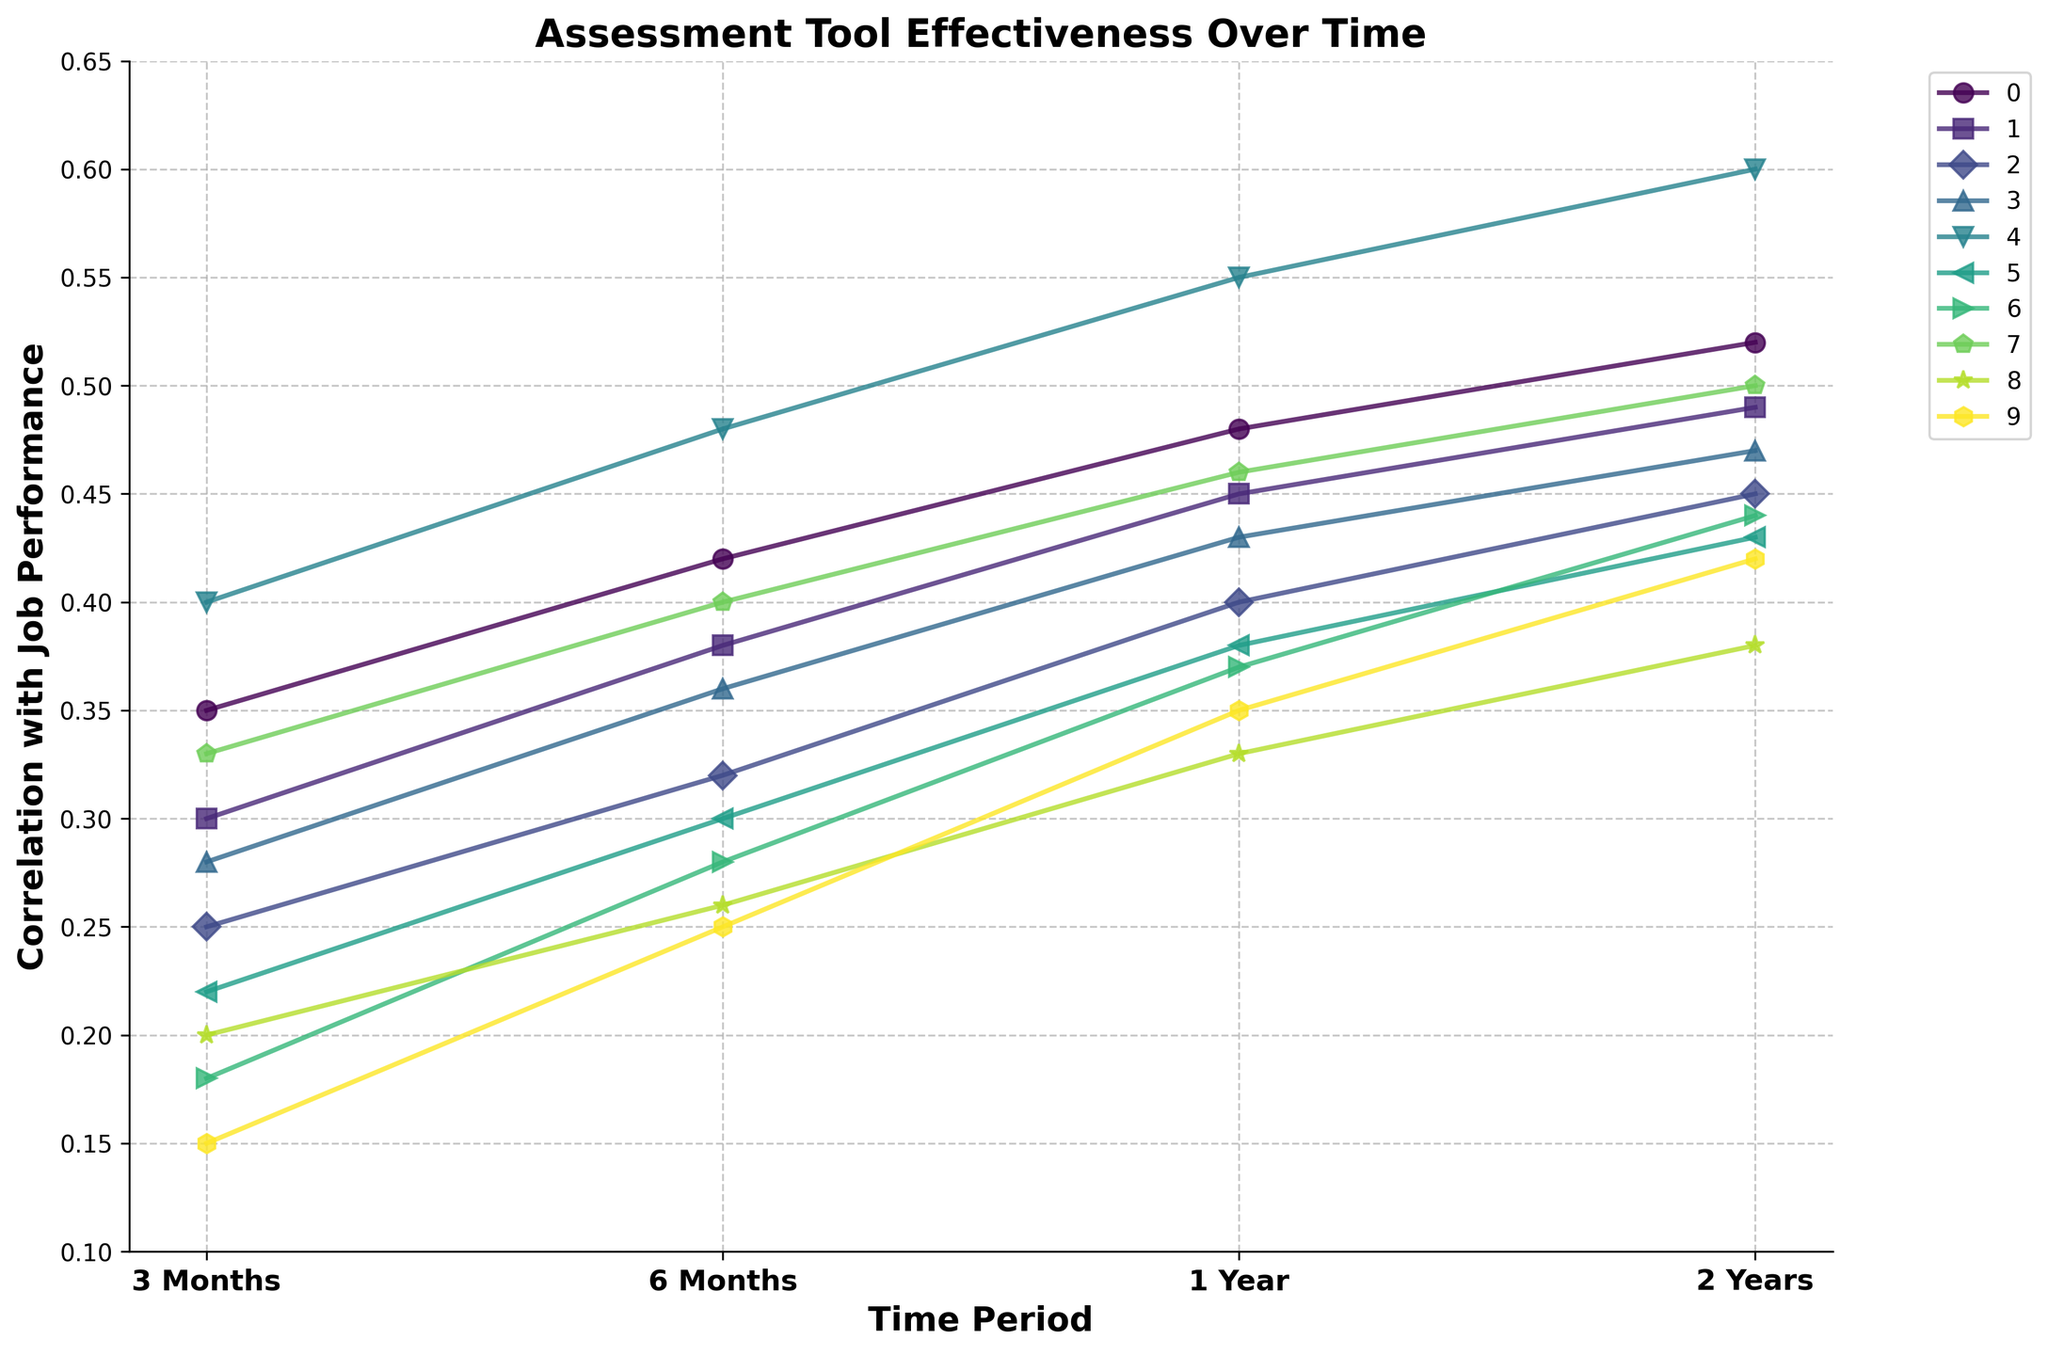What assessment tool shows the highest correlation with job performance after 6 months? Locate the point corresponding to the '6 Months' time period across all lines, and identify the highest point. The Work Sample Test shows the highest correlation score at 6 months.
Answer: Work Sample Test Which assessment tool has the lowest correlation with job performance after 3 months? Look at the correlation values corresponding to the '3 Months' period and find the lowest point. The 360-Degree Feedback has the lowest correlation score at 3 months.
Answer: 360-Degree Feedback How does the correlation for the Cognitive Ability Test change from 3 months to 2 years? Identify the points on the line for the Cognitive Ability Test at '3 Months' (0.35) and '2 Years' (0.52). Calculate the difference: 0.52 - 0.35 = 0.17, indicating an increase.
Answer: Increases by 0.17 Which two assessment tools have the closest correlation values at the 1-year period? Compare the correlation values for each tool at '1 Year'. Structured Interview (0.45) and Skills Assessment (0.46) have the closest values, differing by just 0.01.
Answer: Structured Interview and Skills Assessment What is the average correlation of the Work Sample Test over all time periods? Sum up the correlation values for the Work Sample Test (0.40 + 0.48 + 0.55 + 0.60) and divide by 4. Calculation: (0.40 + 0.48 + 0.55 + 0.60) / 4 = 2.03 / 4 = 0.5075
Answer: 0.51 What is the difference in correlation between the Big Five Personality Test and the Emotional Intelligence Assessment after 1 year? Identify the values at '1 Year' for both tools: Big Five (0.40), Emotional Intelligence (0.38). Calculate the difference: 0.40 - 0.38 = 0.02.
Answer: 0.02 Which assessment tool shows the greatest improvement in correlation from 3 months to 1 year? Calculate the difference for each tool from '3 Months' to '1 Year'. Integrity Test: 0.33 - 0.20 = 0.13. Identify the maximum difference, which is for Work Sample Test: 0.55 - 0.40 = 0.15.
Answer: Work Sample Test At the 2-year period, which two assessment tools have the largest difference in correlation value? Assess the values at '2 Years' for all tools and find the maximum difference. Work Sample Test (0.60) and Integrity Test (0.38) have the largest difference: 0.60 - 0.38 = 0.22.
Answer: Work Sample Test and Integrity Test 